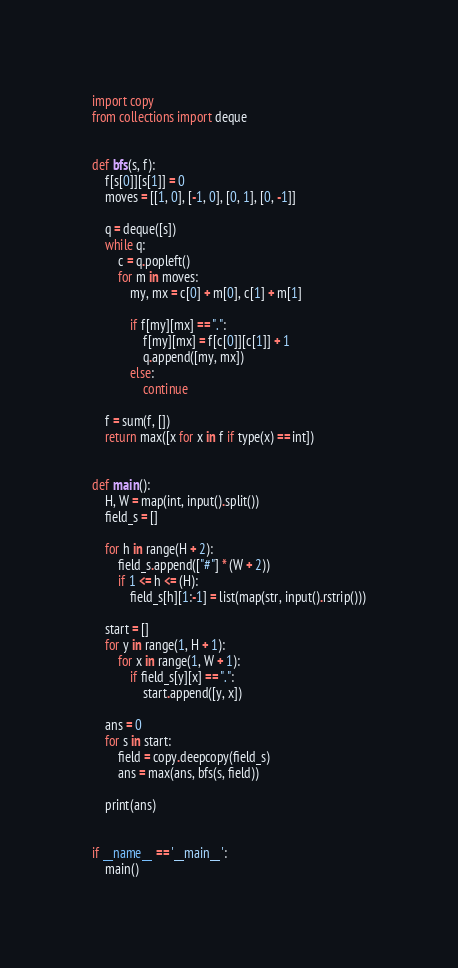Convert code to text. <code><loc_0><loc_0><loc_500><loc_500><_Python_>import copy
from collections import deque


def bfs(s, f):
    f[s[0]][s[1]] = 0
    moves = [[1, 0], [-1, 0], [0, 1], [0, -1]]

    q = deque([s])
    while q:
        c = q.popleft()
        for m in moves:
            my, mx = c[0] + m[0], c[1] + m[1]

            if f[my][mx] == ".":
                f[my][mx] = f[c[0]][c[1]] + 1
                q.append([my, mx])
            else:
                continue

    f = sum(f, [])
    return max([x for x in f if type(x) == int])


def main():
    H, W = map(int, input().split())
    field_s = []

    for h in range(H + 2):
        field_s.append(["#"] * (W + 2))
        if 1 <= h <= (H):
            field_s[h][1:-1] = list(map(str, input().rstrip()))

    start = []
    for y in range(1, H + 1):
        for x in range(1, W + 1):
            if field_s[y][x] == ".":
                start.append([y, x])

    ans = 0
    for s in start:
        field = copy.deepcopy(field_s)
        ans = max(ans, bfs(s, field))

    print(ans)


if __name__ == '__main__':
    main()</code> 